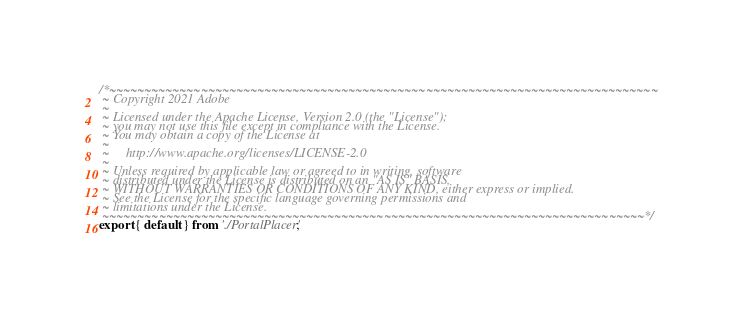Convert code to text. <code><loc_0><loc_0><loc_500><loc_500><_JavaScript_>/*~~~~~~~~~~~~~~~~~~~~~~~~~~~~~~~~~~~~~~~~~~~~~~~~~~~~~~~~~~~~~~~~~~~~~~~~~~~~~~
 ~ Copyright 2021 Adobe
 ~
 ~ Licensed under the Apache License, Version 2.0 (the "License");
 ~ you may not use this file except in compliance with the License.
 ~ You may obtain a copy of the License at
 ~
 ~     http://www.apache.org/licenses/LICENSE-2.0
 ~
 ~ Unless required by applicable law or agreed to in writing, software
 ~ distributed under the License is distributed on an "AS IS" BASIS,
 ~ WITHOUT WARRANTIES OR CONDITIONS OF ANY KIND, either express or implied.
 ~ See the License for the specific language governing permissions and
 ~ limitations under the License.
 ~~~~~~~~~~~~~~~~~~~~~~~~~~~~~~~~~~~~~~~~~~~~~~~~~~~~~~~~~~~~~~~~~~~~~~~~~~~~~*/
export { default } from './PortalPlacer';
</code> 